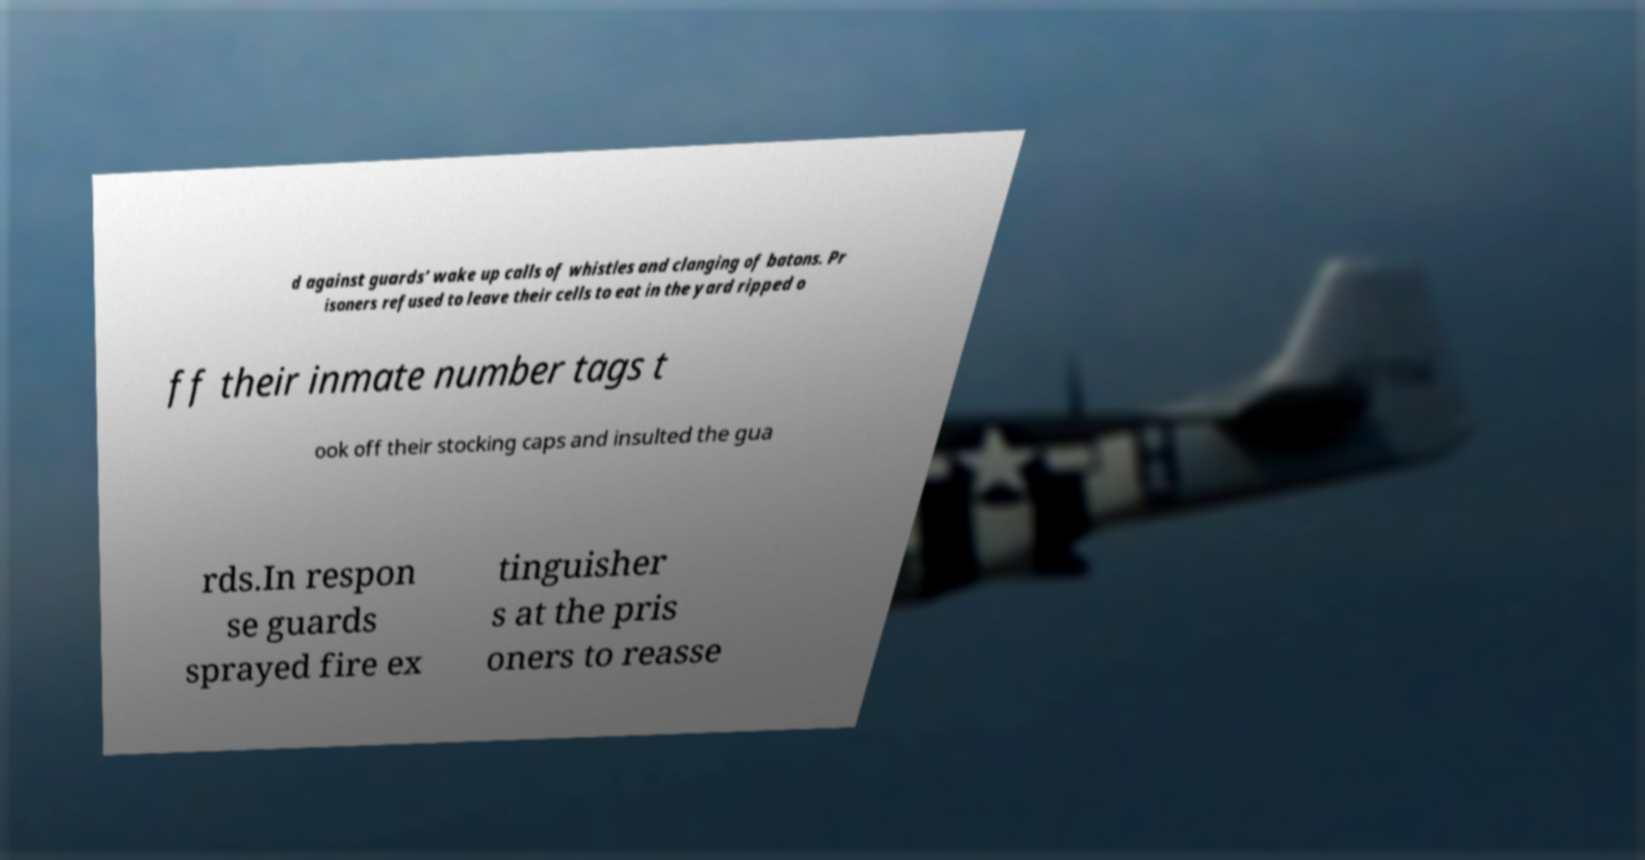For documentation purposes, I need the text within this image transcribed. Could you provide that? d against guards’ wake up calls of whistles and clanging of batons. Pr isoners refused to leave their cells to eat in the yard ripped o ff their inmate number tags t ook off their stocking caps and insulted the gua rds.In respon se guards sprayed fire ex tinguisher s at the pris oners to reasse 